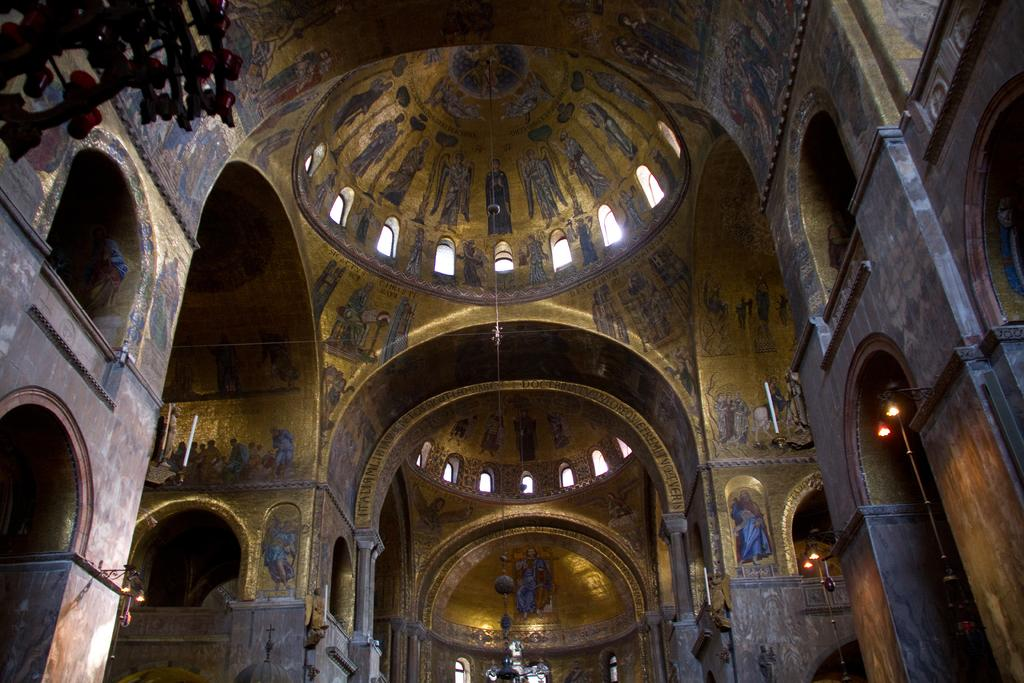What type of building is in the image? There is a church in the image. What decorative elements can be seen on the church? The church has sculptures. What type of artwork is present inside the church? There are pictures of people on the walls of the church. What is the purpose of the hole in the cart in the image? There is no cart or hole present in the image; it features a church with sculptures and pictures of people on the walls. 